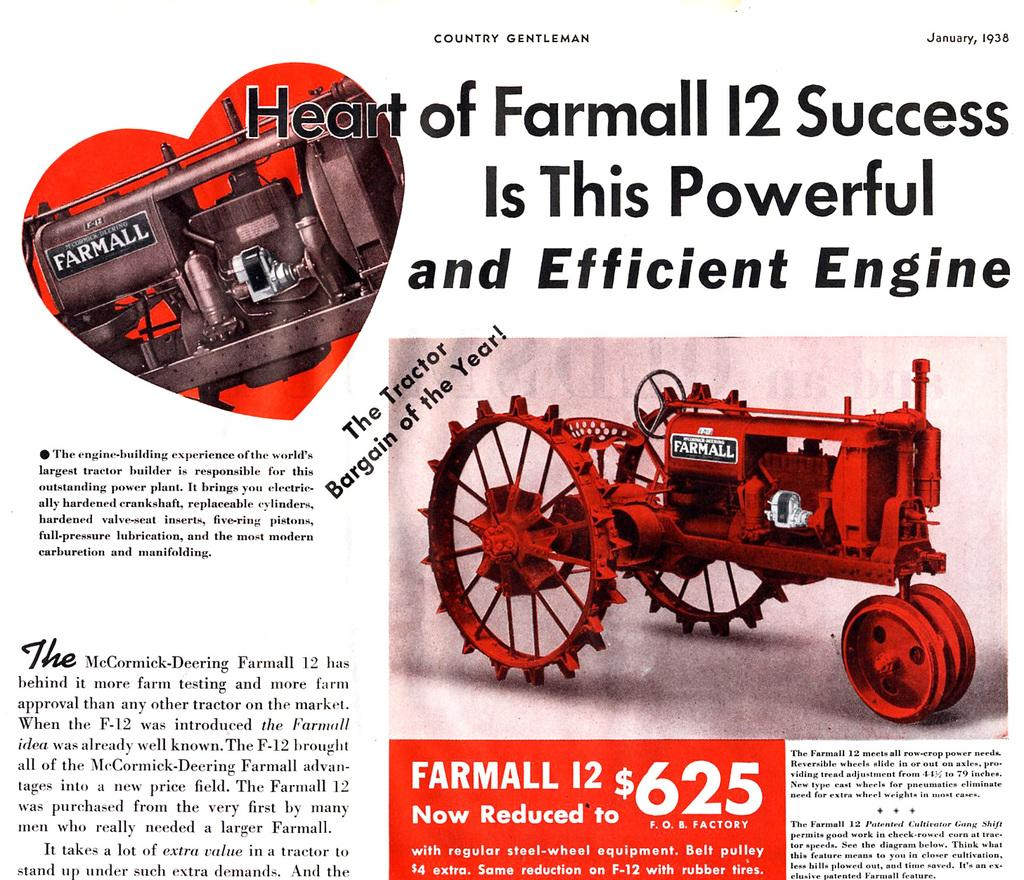What is the main subject of the image? The main subject of the image is a poster. What is depicted on the poster? There is a tractor engine depicted on the poster. Where is the tractor engine located on the poster? The tractor engine is on the right side of the poster. What type of egg is shown in the image? There is no egg present in the image; it features a poster with a tractor engine. How does the wound on the celery appear in the image? There is no celery or wound present in the image; it only shows a poster with a tractor engine. 